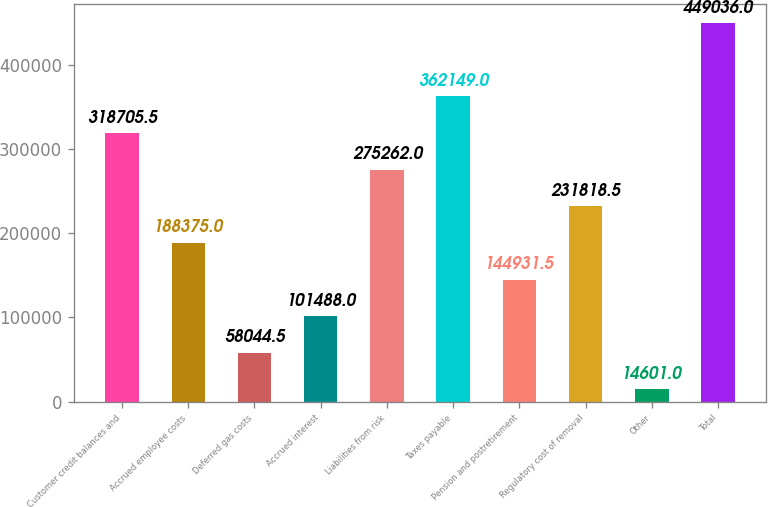Convert chart to OTSL. <chart><loc_0><loc_0><loc_500><loc_500><bar_chart><fcel>Customer credit balances and<fcel>Accrued employee costs<fcel>Deferred gas costs<fcel>Accrued interest<fcel>Liabilities from risk<fcel>Taxes payable<fcel>Pension and postretirement<fcel>Regulatory cost of removal<fcel>Other<fcel>Total<nl><fcel>318706<fcel>188375<fcel>58044.5<fcel>101488<fcel>275262<fcel>362149<fcel>144932<fcel>231818<fcel>14601<fcel>449036<nl></chart> 